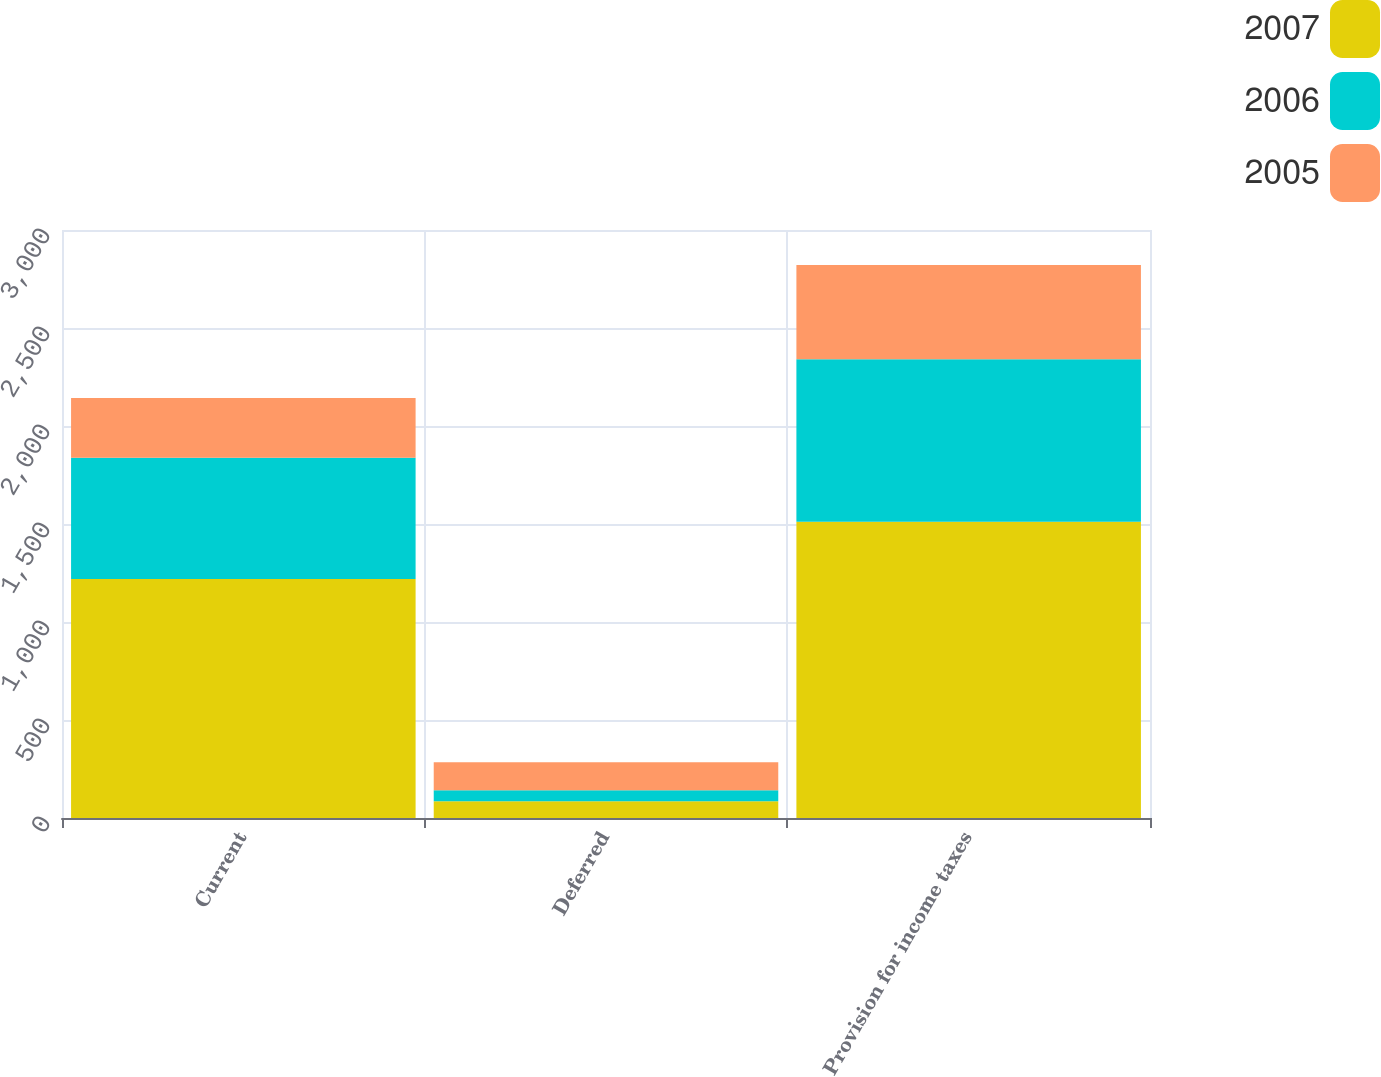Convert chart to OTSL. <chart><loc_0><loc_0><loc_500><loc_500><stacked_bar_chart><ecel><fcel>Current<fcel>Deferred<fcel>Provision for income taxes<nl><fcel>2007<fcel>1219<fcel>85<fcel>1512<nl><fcel>2006<fcel>619<fcel>56<fcel>829<nl><fcel>2005<fcel>305<fcel>144<fcel>480<nl></chart> 